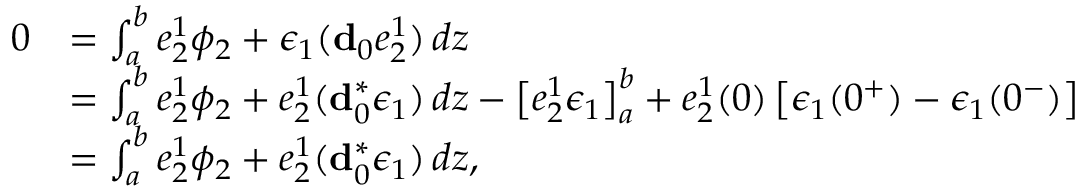<formula> <loc_0><loc_0><loc_500><loc_500>\begin{array} { r l } { 0 } & { = \int _ { a } ^ { b } e _ { 2 } ^ { 1 } \phi _ { 2 } + \epsilon _ { 1 } ( d _ { 0 } e _ { 2 } ^ { 1 } ) \, d z } \\ & { = \int _ { a } ^ { b } e _ { 2 } ^ { 1 } \phi _ { 2 } + e _ { 2 } ^ { 1 } ( d _ { 0 } ^ { \ast } \epsilon _ { 1 } ) \, d z - \left [ e _ { 2 } ^ { 1 } \epsilon _ { 1 } \right ] _ { a } ^ { b } + e _ { 2 } ^ { 1 } ( 0 ) \left [ \epsilon _ { 1 } ( 0 ^ { + } ) - \epsilon _ { 1 } ( 0 ^ { - } ) \right ] } \\ & { = \int _ { a } ^ { b } e _ { 2 } ^ { 1 } \phi _ { 2 } + e _ { 2 } ^ { 1 } ( d _ { 0 } ^ { \ast } \epsilon _ { 1 } ) \, d z , } \end{array}</formula> 